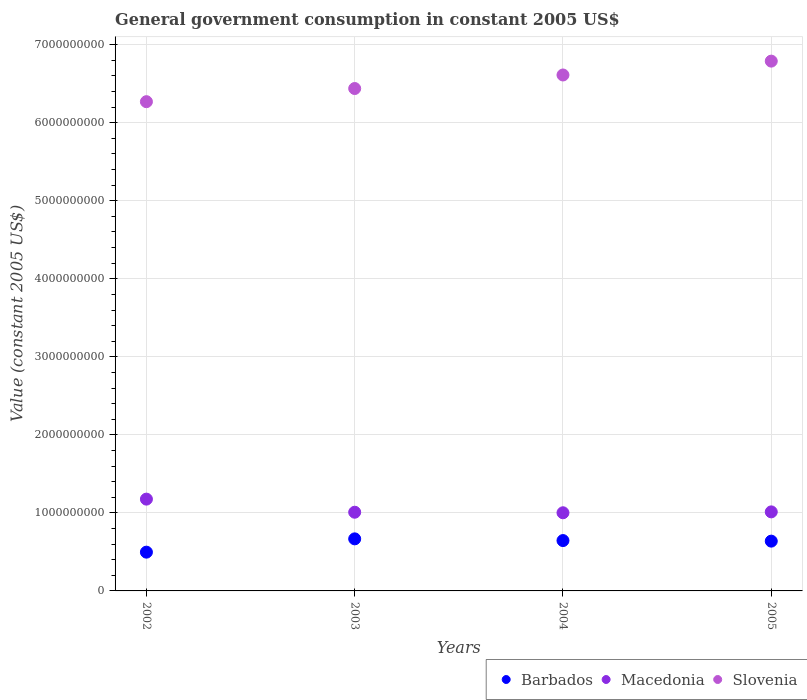What is the government conusmption in Slovenia in 2002?
Your response must be concise. 6.27e+09. Across all years, what is the maximum government conusmption in Slovenia?
Your response must be concise. 6.79e+09. Across all years, what is the minimum government conusmption in Barbados?
Give a very brief answer. 4.97e+08. In which year was the government conusmption in Barbados minimum?
Keep it short and to the point. 2002. What is the total government conusmption in Slovenia in the graph?
Make the answer very short. 2.61e+1. What is the difference between the government conusmption in Slovenia in 2003 and that in 2004?
Provide a short and direct response. -1.74e+08. What is the difference between the government conusmption in Barbados in 2004 and the government conusmption in Slovenia in 2002?
Offer a very short reply. -5.62e+09. What is the average government conusmption in Barbados per year?
Offer a very short reply. 6.12e+08. In the year 2004, what is the difference between the government conusmption in Macedonia and government conusmption in Barbados?
Your answer should be very brief. 3.56e+08. What is the ratio of the government conusmption in Slovenia in 2002 to that in 2003?
Your answer should be very brief. 0.97. What is the difference between the highest and the second highest government conusmption in Macedonia?
Give a very brief answer. 1.63e+08. What is the difference between the highest and the lowest government conusmption in Barbados?
Offer a very short reply. 1.70e+08. Is the government conusmption in Macedonia strictly less than the government conusmption in Barbados over the years?
Offer a very short reply. No. Where does the legend appear in the graph?
Provide a succinct answer. Bottom right. How many legend labels are there?
Your answer should be compact. 3. How are the legend labels stacked?
Your response must be concise. Horizontal. What is the title of the graph?
Offer a terse response. General government consumption in constant 2005 US$. What is the label or title of the Y-axis?
Give a very brief answer. Value (constant 2005 US$). What is the Value (constant 2005 US$) of Barbados in 2002?
Ensure brevity in your answer.  4.97e+08. What is the Value (constant 2005 US$) in Macedonia in 2002?
Provide a succinct answer. 1.18e+09. What is the Value (constant 2005 US$) in Slovenia in 2002?
Provide a succinct answer. 6.27e+09. What is the Value (constant 2005 US$) in Barbados in 2003?
Ensure brevity in your answer.  6.67e+08. What is the Value (constant 2005 US$) in Macedonia in 2003?
Keep it short and to the point. 1.01e+09. What is the Value (constant 2005 US$) in Slovenia in 2003?
Keep it short and to the point. 6.44e+09. What is the Value (constant 2005 US$) in Barbados in 2004?
Your answer should be very brief. 6.45e+08. What is the Value (constant 2005 US$) of Macedonia in 2004?
Keep it short and to the point. 1.00e+09. What is the Value (constant 2005 US$) of Slovenia in 2004?
Ensure brevity in your answer.  6.61e+09. What is the Value (constant 2005 US$) of Barbados in 2005?
Give a very brief answer. 6.38e+08. What is the Value (constant 2005 US$) of Macedonia in 2005?
Keep it short and to the point. 1.01e+09. What is the Value (constant 2005 US$) in Slovenia in 2005?
Offer a very short reply. 6.79e+09. Across all years, what is the maximum Value (constant 2005 US$) in Barbados?
Your answer should be compact. 6.67e+08. Across all years, what is the maximum Value (constant 2005 US$) of Macedonia?
Offer a terse response. 1.18e+09. Across all years, what is the maximum Value (constant 2005 US$) of Slovenia?
Ensure brevity in your answer.  6.79e+09. Across all years, what is the minimum Value (constant 2005 US$) of Barbados?
Offer a terse response. 4.97e+08. Across all years, what is the minimum Value (constant 2005 US$) of Macedonia?
Make the answer very short. 1.00e+09. Across all years, what is the minimum Value (constant 2005 US$) of Slovenia?
Your answer should be compact. 6.27e+09. What is the total Value (constant 2005 US$) in Barbados in the graph?
Offer a very short reply. 2.45e+09. What is the total Value (constant 2005 US$) in Macedonia in the graph?
Give a very brief answer. 4.20e+09. What is the total Value (constant 2005 US$) in Slovenia in the graph?
Your answer should be very brief. 2.61e+1. What is the difference between the Value (constant 2005 US$) of Barbados in 2002 and that in 2003?
Offer a very short reply. -1.70e+08. What is the difference between the Value (constant 2005 US$) in Macedonia in 2002 and that in 2003?
Ensure brevity in your answer.  1.68e+08. What is the difference between the Value (constant 2005 US$) in Slovenia in 2002 and that in 2003?
Offer a very short reply. -1.69e+08. What is the difference between the Value (constant 2005 US$) in Barbados in 2002 and that in 2004?
Give a very brief answer. -1.49e+08. What is the difference between the Value (constant 2005 US$) of Macedonia in 2002 and that in 2004?
Your answer should be very brief. 1.75e+08. What is the difference between the Value (constant 2005 US$) of Slovenia in 2002 and that in 2004?
Make the answer very short. -3.42e+08. What is the difference between the Value (constant 2005 US$) in Barbados in 2002 and that in 2005?
Offer a very short reply. -1.41e+08. What is the difference between the Value (constant 2005 US$) in Macedonia in 2002 and that in 2005?
Offer a very short reply. 1.63e+08. What is the difference between the Value (constant 2005 US$) of Slovenia in 2002 and that in 2005?
Provide a short and direct response. -5.20e+08. What is the difference between the Value (constant 2005 US$) in Barbados in 2003 and that in 2004?
Your response must be concise. 2.19e+07. What is the difference between the Value (constant 2005 US$) of Macedonia in 2003 and that in 2004?
Keep it short and to the point. 6.96e+06. What is the difference between the Value (constant 2005 US$) in Slovenia in 2003 and that in 2004?
Ensure brevity in your answer.  -1.74e+08. What is the difference between the Value (constant 2005 US$) in Barbados in 2003 and that in 2005?
Provide a short and direct response. 2.92e+07. What is the difference between the Value (constant 2005 US$) of Macedonia in 2003 and that in 2005?
Make the answer very short. -4.46e+06. What is the difference between the Value (constant 2005 US$) of Slovenia in 2003 and that in 2005?
Offer a terse response. -3.51e+08. What is the difference between the Value (constant 2005 US$) in Barbados in 2004 and that in 2005?
Keep it short and to the point. 7.31e+06. What is the difference between the Value (constant 2005 US$) of Macedonia in 2004 and that in 2005?
Your answer should be compact. -1.14e+07. What is the difference between the Value (constant 2005 US$) of Slovenia in 2004 and that in 2005?
Offer a terse response. -1.78e+08. What is the difference between the Value (constant 2005 US$) of Barbados in 2002 and the Value (constant 2005 US$) of Macedonia in 2003?
Your response must be concise. -5.12e+08. What is the difference between the Value (constant 2005 US$) in Barbados in 2002 and the Value (constant 2005 US$) in Slovenia in 2003?
Your response must be concise. -5.94e+09. What is the difference between the Value (constant 2005 US$) of Macedonia in 2002 and the Value (constant 2005 US$) of Slovenia in 2003?
Your answer should be compact. -5.26e+09. What is the difference between the Value (constant 2005 US$) of Barbados in 2002 and the Value (constant 2005 US$) of Macedonia in 2004?
Make the answer very short. -5.05e+08. What is the difference between the Value (constant 2005 US$) in Barbados in 2002 and the Value (constant 2005 US$) in Slovenia in 2004?
Give a very brief answer. -6.12e+09. What is the difference between the Value (constant 2005 US$) in Macedonia in 2002 and the Value (constant 2005 US$) in Slovenia in 2004?
Your answer should be compact. -5.44e+09. What is the difference between the Value (constant 2005 US$) of Barbados in 2002 and the Value (constant 2005 US$) of Macedonia in 2005?
Give a very brief answer. -5.16e+08. What is the difference between the Value (constant 2005 US$) of Barbados in 2002 and the Value (constant 2005 US$) of Slovenia in 2005?
Your response must be concise. -6.29e+09. What is the difference between the Value (constant 2005 US$) in Macedonia in 2002 and the Value (constant 2005 US$) in Slovenia in 2005?
Your response must be concise. -5.61e+09. What is the difference between the Value (constant 2005 US$) of Barbados in 2003 and the Value (constant 2005 US$) of Macedonia in 2004?
Offer a very short reply. -3.34e+08. What is the difference between the Value (constant 2005 US$) of Barbados in 2003 and the Value (constant 2005 US$) of Slovenia in 2004?
Your answer should be compact. -5.94e+09. What is the difference between the Value (constant 2005 US$) in Macedonia in 2003 and the Value (constant 2005 US$) in Slovenia in 2004?
Your answer should be very brief. -5.60e+09. What is the difference between the Value (constant 2005 US$) in Barbados in 2003 and the Value (constant 2005 US$) in Macedonia in 2005?
Your answer should be very brief. -3.46e+08. What is the difference between the Value (constant 2005 US$) of Barbados in 2003 and the Value (constant 2005 US$) of Slovenia in 2005?
Your answer should be compact. -6.12e+09. What is the difference between the Value (constant 2005 US$) in Macedonia in 2003 and the Value (constant 2005 US$) in Slovenia in 2005?
Keep it short and to the point. -5.78e+09. What is the difference between the Value (constant 2005 US$) of Barbados in 2004 and the Value (constant 2005 US$) of Macedonia in 2005?
Your answer should be very brief. -3.68e+08. What is the difference between the Value (constant 2005 US$) of Barbados in 2004 and the Value (constant 2005 US$) of Slovenia in 2005?
Keep it short and to the point. -6.14e+09. What is the difference between the Value (constant 2005 US$) in Macedonia in 2004 and the Value (constant 2005 US$) in Slovenia in 2005?
Keep it short and to the point. -5.79e+09. What is the average Value (constant 2005 US$) of Barbados per year?
Offer a very short reply. 6.12e+08. What is the average Value (constant 2005 US$) in Macedonia per year?
Provide a short and direct response. 1.05e+09. What is the average Value (constant 2005 US$) of Slovenia per year?
Your answer should be compact. 6.53e+09. In the year 2002, what is the difference between the Value (constant 2005 US$) in Barbados and Value (constant 2005 US$) in Macedonia?
Ensure brevity in your answer.  -6.80e+08. In the year 2002, what is the difference between the Value (constant 2005 US$) in Barbados and Value (constant 2005 US$) in Slovenia?
Your answer should be compact. -5.77e+09. In the year 2002, what is the difference between the Value (constant 2005 US$) in Macedonia and Value (constant 2005 US$) in Slovenia?
Give a very brief answer. -5.09e+09. In the year 2003, what is the difference between the Value (constant 2005 US$) in Barbados and Value (constant 2005 US$) in Macedonia?
Give a very brief answer. -3.41e+08. In the year 2003, what is the difference between the Value (constant 2005 US$) of Barbados and Value (constant 2005 US$) of Slovenia?
Offer a terse response. -5.77e+09. In the year 2003, what is the difference between the Value (constant 2005 US$) in Macedonia and Value (constant 2005 US$) in Slovenia?
Your response must be concise. -5.43e+09. In the year 2004, what is the difference between the Value (constant 2005 US$) of Barbados and Value (constant 2005 US$) of Macedonia?
Ensure brevity in your answer.  -3.56e+08. In the year 2004, what is the difference between the Value (constant 2005 US$) of Barbados and Value (constant 2005 US$) of Slovenia?
Give a very brief answer. -5.97e+09. In the year 2004, what is the difference between the Value (constant 2005 US$) of Macedonia and Value (constant 2005 US$) of Slovenia?
Provide a short and direct response. -5.61e+09. In the year 2005, what is the difference between the Value (constant 2005 US$) of Barbados and Value (constant 2005 US$) of Macedonia?
Provide a succinct answer. -3.75e+08. In the year 2005, what is the difference between the Value (constant 2005 US$) in Barbados and Value (constant 2005 US$) in Slovenia?
Give a very brief answer. -6.15e+09. In the year 2005, what is the difference between the Value (constant 2005 US$) of Macedonia and Value (constant 2005 US$) of Slovenia?
Keep it short and to the point. -5.78e+09. What is the ratio of the Value (constant 2005 US$) in Barbados in 2002 to that in 2003?
Keep it short and to the point. 0.74. What is the ratio of the Value (constant 2005 US$) in Macedonia in 2002 to that in 2003?
Your answer should be compact. 1.17. What is the ratio of the Value (constant 2005 US$) in Slovenia in 2002 to that in 2003?
Make the answer very short. 0.97. What is the ratio of the Value (constant 2005 US$) in Barbados in 2002 to that in 2004?
Your response must be concise. 0.77. What is the ratio of the Value (constant 2005 US$) of Macedonia in 2002 to that in 2004?
Ensure brevity in your answer.  1.17. What is the ratio of the Value (constant 2005 US$) of Slovenia in 2002 to that in 2004?
Your answer should be compact. 0.95. What is the ratio of the Value (constant 2005 US$) in Barbados in 2002 to that in 2005?
Ensure brevity in your answer.  0.78. What is the ratio of the Value (constant 2005 US$) of Macedonia in 2002 to that in 2005?
Provide a succinct answer. 1.16. What is the ratio of the Value (constant 2005 US$) of Slovenia in 2002 to that in 2005?
Keep it short and to the point. 0.92. What is the ratio of the Value (constant 2005 US$) of Barbados in 2003 to that in 2004?
Ensure brevity in your answer.  1.03. What is the ratio of the Value (constant 2005 US$) of Slovenia in 2003 to that in 2004?
Offer a terse response. 0.97. What is the ratio of the Value (constant 2005 US$) in Barbados in 2003 to that in 2005?
Your answer should be compact. 1.05. What is the ratio of the Value (constant 2005 US$) of Macedonia in 2003 to that in 2005?
Your answer should be very brief. 1. What is the ratio of the Value (constant 2005 US$) of Slovenia in 2003 to that in 2005?
Your answer should be very brief. 0.95. What is the ratio of the Value (constant 2005 US$) of Barbados in 2004 to that in 2005?
Provide a short and direct response. 1.01. What is the ratio of the Value (constant 2005 US$) in Macedonia in 2004 to that in 2005?
Keep it short and to the point. 0.99. What is the ratio of the Value (constant 2005 US$) of Slovenia in 2004 to that in 2005?
Offer a very short reply. 0.97. What is the difference between the highest and the second highest Value (constant 2005 US$) in Barbados?
Your response must be concise. 2.19e+07. What is the difference between the highest and the second highest Value (constant 2005 US$) of Macedonia?
Your answer should be compact. 1.63e+08. What is the difference between the highest and the second highest Value (constant 2005 US$) in Slovenia?
Make the answer very short. 1.78e+08. What is the difference between the highest and the lowest Value (constant 2005 US$) in Barbados?
Provide a succinct answer. 1.70e+08. What is the difference between the highest and the lowest Value (constant 2005 US$) in Macedonia?
Provide a short and direct response. 1.75e+08. What is the difference between the highest and the lowest Value (constant 2005 US$) of Slovenia?
Keep it short and to the point. 5.20e+08. 